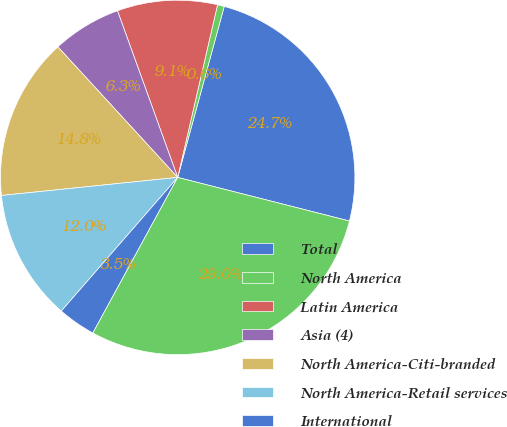Convert chart. <chart><loc_0><loc_0><loc_500><loc_500><pie_chart><fcel>Total<fcel>North America<fcel>Latin America<fcel>Asia (4)<fcel>North America-Citi-branded<fcel>North America-Retail services<fcel>International<fcel>Total Citigroup<nl><fcel>24.73%<fcel>0.62%<fcel>9.13%<fcel>6.3%<fcel>14.81%<fcel>11.97%<fcel>3.46%<fcel>28.99%<nl></chart> 